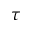<formula> <loc_0><loc_0><loc_500><loc_500>\tau</formula> 